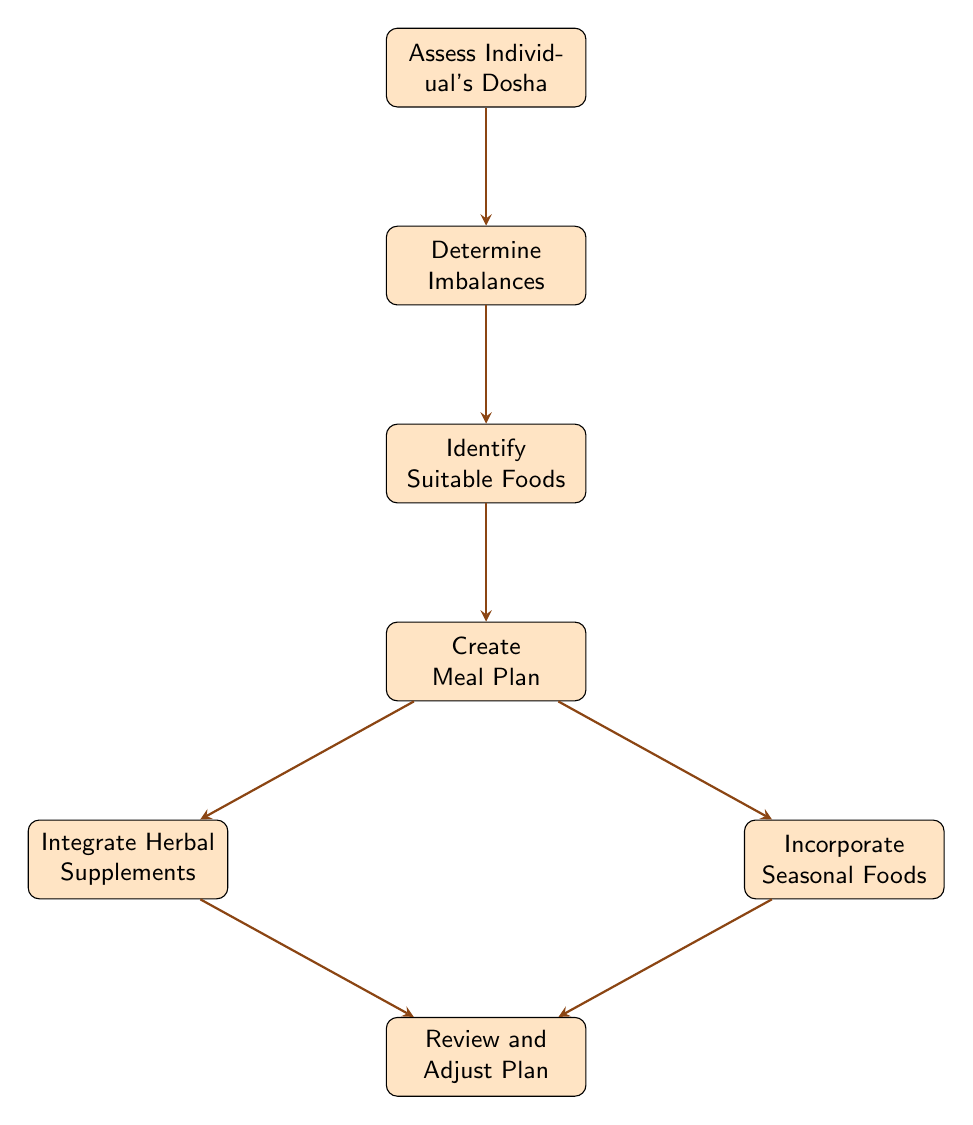What is the first step in the diagram? The diagram shows that the first step is at the top node labeled "Assess Individual's Dosha."
Answer: Assess Individual's Dosha How many nodes are in the diagram? The diagram includes seven nodes, each representing a distinct step in creating a balanced diet plan.
Answer: 7 What follows "Determine Imbalances" in the flow? The flow continues from "Determine Imbalances" to the next node labeled "Identify Suitable Foods."
Answer: Identify Suitable Foods Which step is connected to both "Integrate Herbal Supplements" and "Incorporate Seasonal Foods"? The step that connects to both is "Create Meal Plan," as shown in the diagram leading to both of those nodes.
Answer: Create Meal Plan What is the last step in the process? The last step in the diagram, positioned at the bottom, is "Review and Adjust Plan."
Answer: Review and Adjust Plan How many arrows are leading out from "Create Meal Plan"? There are two arrows leading out from "Create Meal Plan," one towards "Integrate Herbal Supplements" and another towards "Incorporate Seasonal Foods."
Answer: 2 Which node does "Integrated Herbal Supplements" lead to? "Integrate Herbal Supplements" leads to the final step in the diagram, which is "Review and Adjust Plan."
Answer: Review and Adjust Plan What is the relationship between "Identify Suitable Foods" and "Create Meal Plan"? There is a direct flow connection from "Identify Suitable Foods" to "Create Meal Plan," indicating that the identified foods are used in meal planning.
Answer: Create Meal Plan 